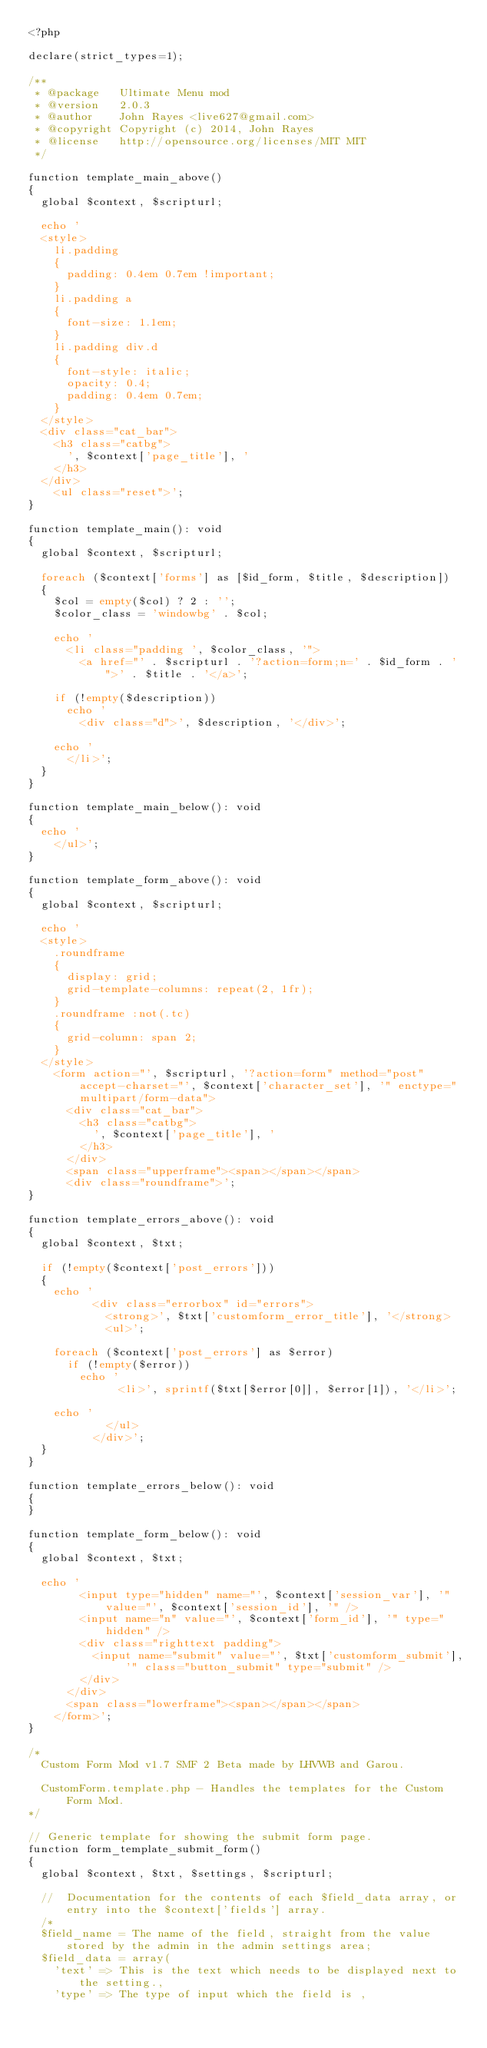<code> <loc_0><loc_0><loc_500><loc_500><_PHP_><?php

declare(strict_types=1);

/**
 * @package   Ultimate Menu mod
 * @version   2.0.3
 * @author    John Rayes <live627@gmail.com>
 * @copyright Copyright (c) 2014, John Rayes
 * @license   http://opensource.org/licenses/MIT MIT
 */
 
function template_main_above()
{
	global $context, $scripturl;

	echo '
	<style>
		li.padding
		{
			padding: 0.4em 0.7em !important;
		}
		li.padding a
		{
			font-size: 1.1em;
		}
		li.padding div.d
		{
			font-style: italic;
			opacity: 0.4;
			padding: 0.4em 0.7em;
		}
	</style>
	<div class="cat_bar">
		<h3 class="catbg">
			', $context['page_title'], '
		</h3>
	</div>
		<ul class="reset">';
}

function template_main(): void
{
	global $context, $scripturl;

	foreach ($context['forms'] as [$id_form, $title, $description])
	{
		$col = empty($col) ? 2 : '';
		$color_class = 'windowbg' . $col;

		echo '
			<li class="padding ', $color_class, '">
				<a href="' . $scripturl . '?action=form;n=' . $id_form . '">' . $title . '</a>';

		if (!empty($description))
			echo '
				<div class="d">', $description, '</div>';

		echo '
			</li>';
	}
}

function template_main_below(): void
{
	echo '
		</ul>';
}

function template_form_above(): void
{
	global $context, $scripturl;

	echo '
	<style>
		.roundframe
		{
			display: grid;
			grid-template-columns: repeat(2, 1fr);
		}
		.roundframe :not(.tc)
		{
			grid-column: span 2;
		}
	</style>
		<form action="', $scripturl, '?action=form" method="post" accept-charset="', $context['character_set'], '" enctype="multipart/form-data">
			<div class="cat_bar">
				<h3 class="catbg">
					', $context['page_title'], '
				</h3>
			</div>
			<span class="upperframe"><span></span></span>
			<div class="roundframe">';
}

function template_errors_above(): void
{
	global $context, $txt;

	if (!empty($context['post_errors']))
	{
		echo '
					<div class="errorbox" id="errors">
						<strong>', $txt['customform_error_title'], '</strong>
						<ul>';

		foreach ($context['post_errors'] as $error)
			if (!empty($error))
				echo '
							<li>', sprintf($txt[$error[0]], $error[1]), '</li>';

		echo '
						</ul>
					</div>';
	}
}

function template_errors_below(): void
{
}

function template_form_below(): void
{
	global $context, $txt;

	echo '
				<input type="hidden" name="', $context['session_var'], '" value="', $context['session_id'], '" />
				<input name="n" value="', $context['form_id'], '" type="hidden" />
				<div class="righttext padding">
					<input name="submit" value="', $txt['customform_submit'], '" class="button_submit" type="submit" />
				</div>
			</div>
			<span class="lowerframe"><span></span></span>
		</form>';
}

/*
	Custom Form Mod v1.7 SMF 2 Beta made by LHVWB and Garou.
	
	CustomForm.template.php - Handles the templates for the Custom Form Mod.
*/

// Generic template for showing the submit form page.
function form_template_submit_form()
{
	global $context, $txt, $settings, $scripturl;

	//	Documentation for the contents of each $field_data array, or entry into the $context['fields'] array.
	/*
	$field_name = The name of the field, straight from the value stored by the admin in the admin settings area;
	$field_data = array(
		'text' => This is the text which needs to be displayed next to the setting.,
		'type' => The type of input which the field is ,</code> 